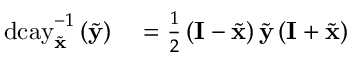Convert formula to latex. <formula><loc_0><loc_0><loc_500><loc_500>\begin{array} { r l } { d c a y _ { \tilde { x } } ^ { - 1 } \left ( \tilde { y } \right ) } & = \frac { 1 } { 2 } \left ( I - \tilde { x } \right ) \tilde { y } \left ( I + \tilde { x } \right ) } \end{array}</formula> 